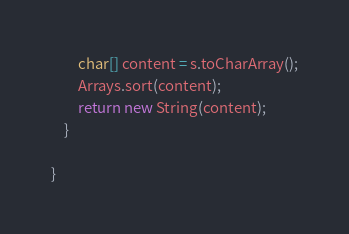Convert code to text. <code><loc_0><loc_0><loc_500><loc_500><_Java_>        char[] content = s.toCharArray();
        Arrays.sort(content);
        return new String(content);
    }

}
</code> 